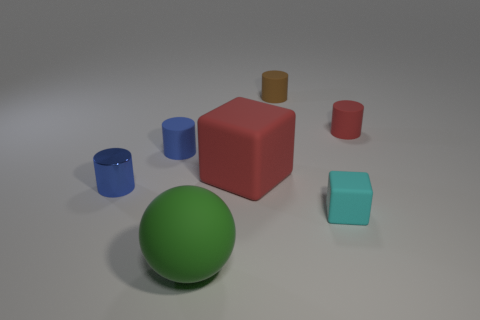What is the material of the large thing that is in front of the large red cube?
Keep it short and to the point. Rubber. Do the sphere and the cyan block have the same size?
Your answer should be compact. No. How many other objects are the same size as the brown cylinder?
Offer a very short reply. 4. Is the metal cylinder the same color as the tiny block?
Provide a short and direct response. No. What is the shape of the blue object that is behind the cylinder that is in front of the tiny rubber cylinder that is on the left side of the big block?
Give a very brief answer. Cylinder. How many objects are either blue cylinders behind the red rubber cube or objects that are to the right of the blue matte thing?
Your answer should be very brief. 6. How big is the blue cylinder behind the red object on the left side of the brown thing?
Provide a short and direct response. Small. Does the small rubber object that is left of the small brown rubber cylinder have the same color as the tiny matte cube?
Give a very brief answer. No. Are there any small brown things of the same shape as the green rubber object?
Keep it short and to the point. No. There is a cube that is the same size as the red cylinder; what is its color?
Provide a succinct answer. Cyan. 